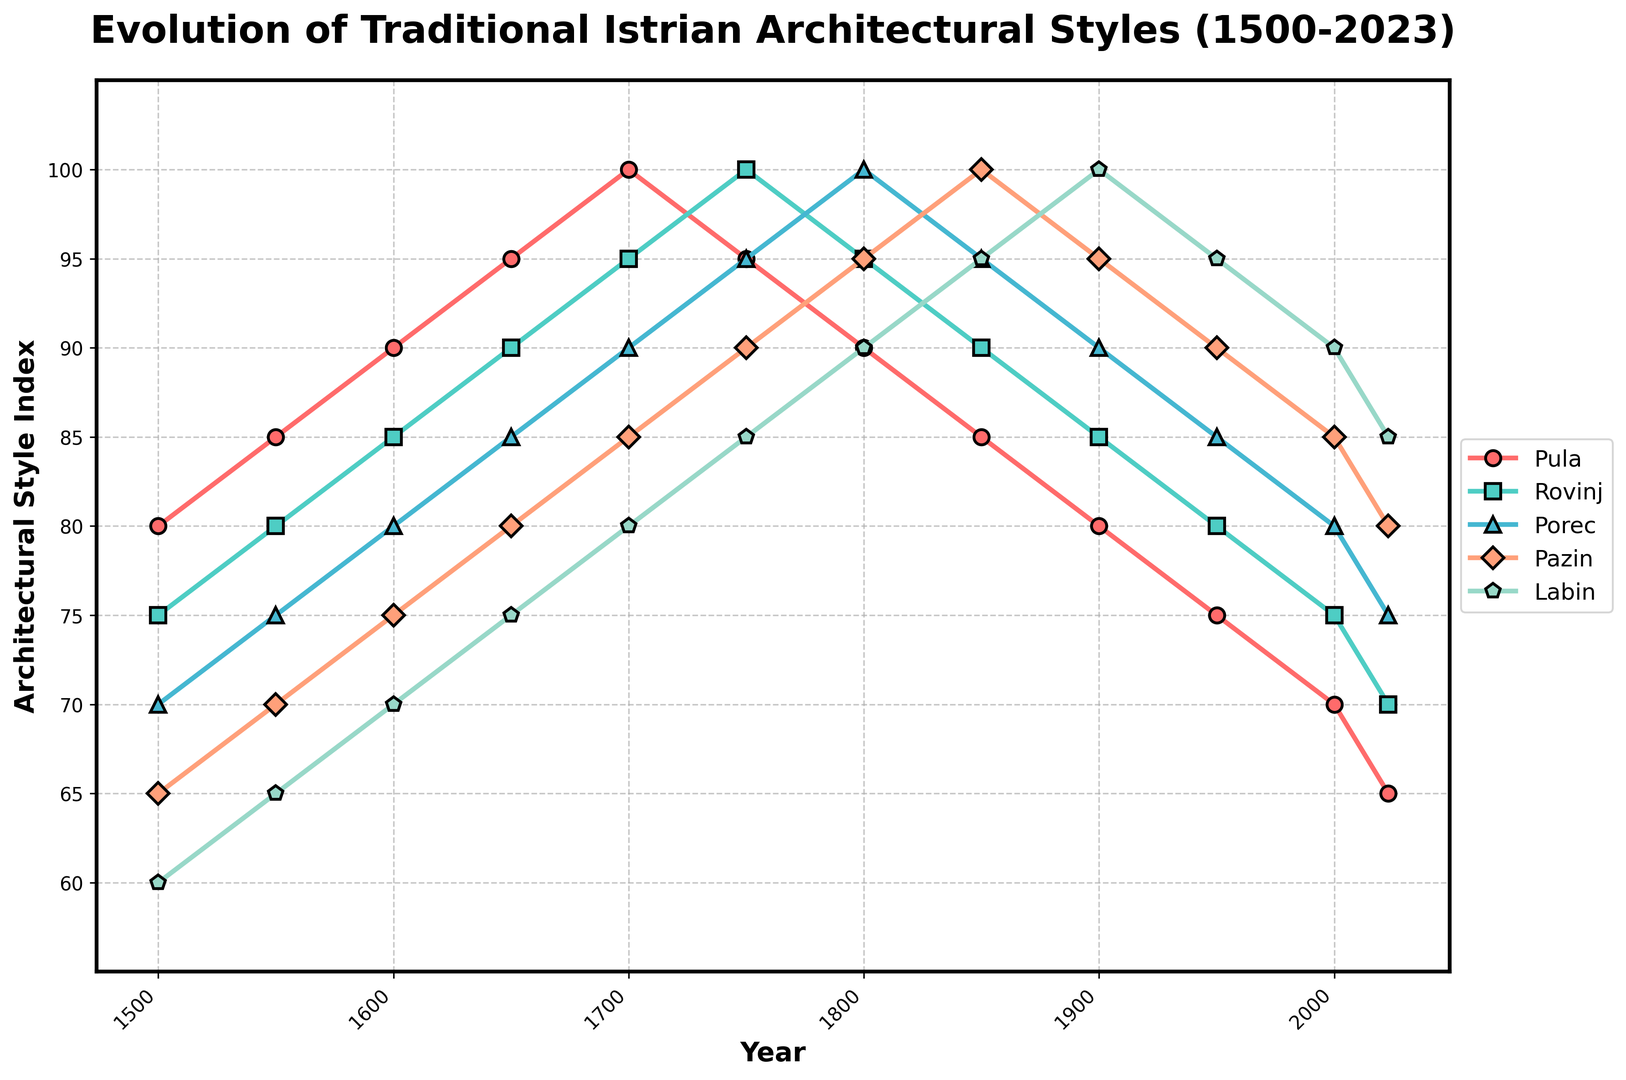What's the year when architectural style in Rovinj peaked highest? In the figure, we observe that Rovinj reached its highest architectural style index in the year 1750, where the line for Rovinj is at its peak value.
Answer: 1750 Which town had the highest architectural style index in 2023? The figure indicates that Labin has the highest architectural style index in 2023 since its marker is positioned the highest among all the towns.
Answer: Labin Between 1500 and 2023, which town showed the most significant decline in the architectural style index? Comparing all towns, Pula's index decreases from 80 in 1500 to 65 in 2023, which marks the most significant drop.
Answer: Pula What is the average architectural style index of Porec from 1800 to 2023? The values for Porec from 1800 to 2023 are 100, 95, 90, 85, 80, 75. Adding them up gives 525, and there are 6 data points. Thus, the average is 525/6.
Answer: 87.5 Which two towns had identical architectural style indices and in which year? The figure shows that in 1750, Rovinj and Porec both had an index of 100 as their data points coincide at that level.
Answer: Rovinj and Porec, 1750 By how much did the architectural style index of Pazin change from 1700 to 1900? Pazin's index is 85 in 1700 and rises to 95 by 1900. The difference between these values is 95 - 85.
Answer: 10 What trends can you observe in the architectural style of Pula over the years? Observing Pula's line on the graph, it initially rises until 1700, then declines steadily through 2023.
Answer: Initial rise, then steady decline Which town had a steady increase in its architectural style index until 1850 and then began to decline? The line for Labin increases consistently until 1850 and then begins to decline, as visualized by its peak in 1900 and subsequent downward slope.
Answer: Labin Compare the trends of Pula and Rovinj’s architectural styles from 1500 to 2023. Pula’s trend shows a peak until 1700 and a descending pattern after, whereas Rovinj shows a continuous increase until 1750 and declines steadily thereafter.
Answer: Different peak timings; both decline after peak What's the difference in the architectural style index between Porec and Labin in the year 1600? In 1600, Porec has an index of 80, while Labin has 70. The difference is calculated as 80 - 70.
Answer: 10 